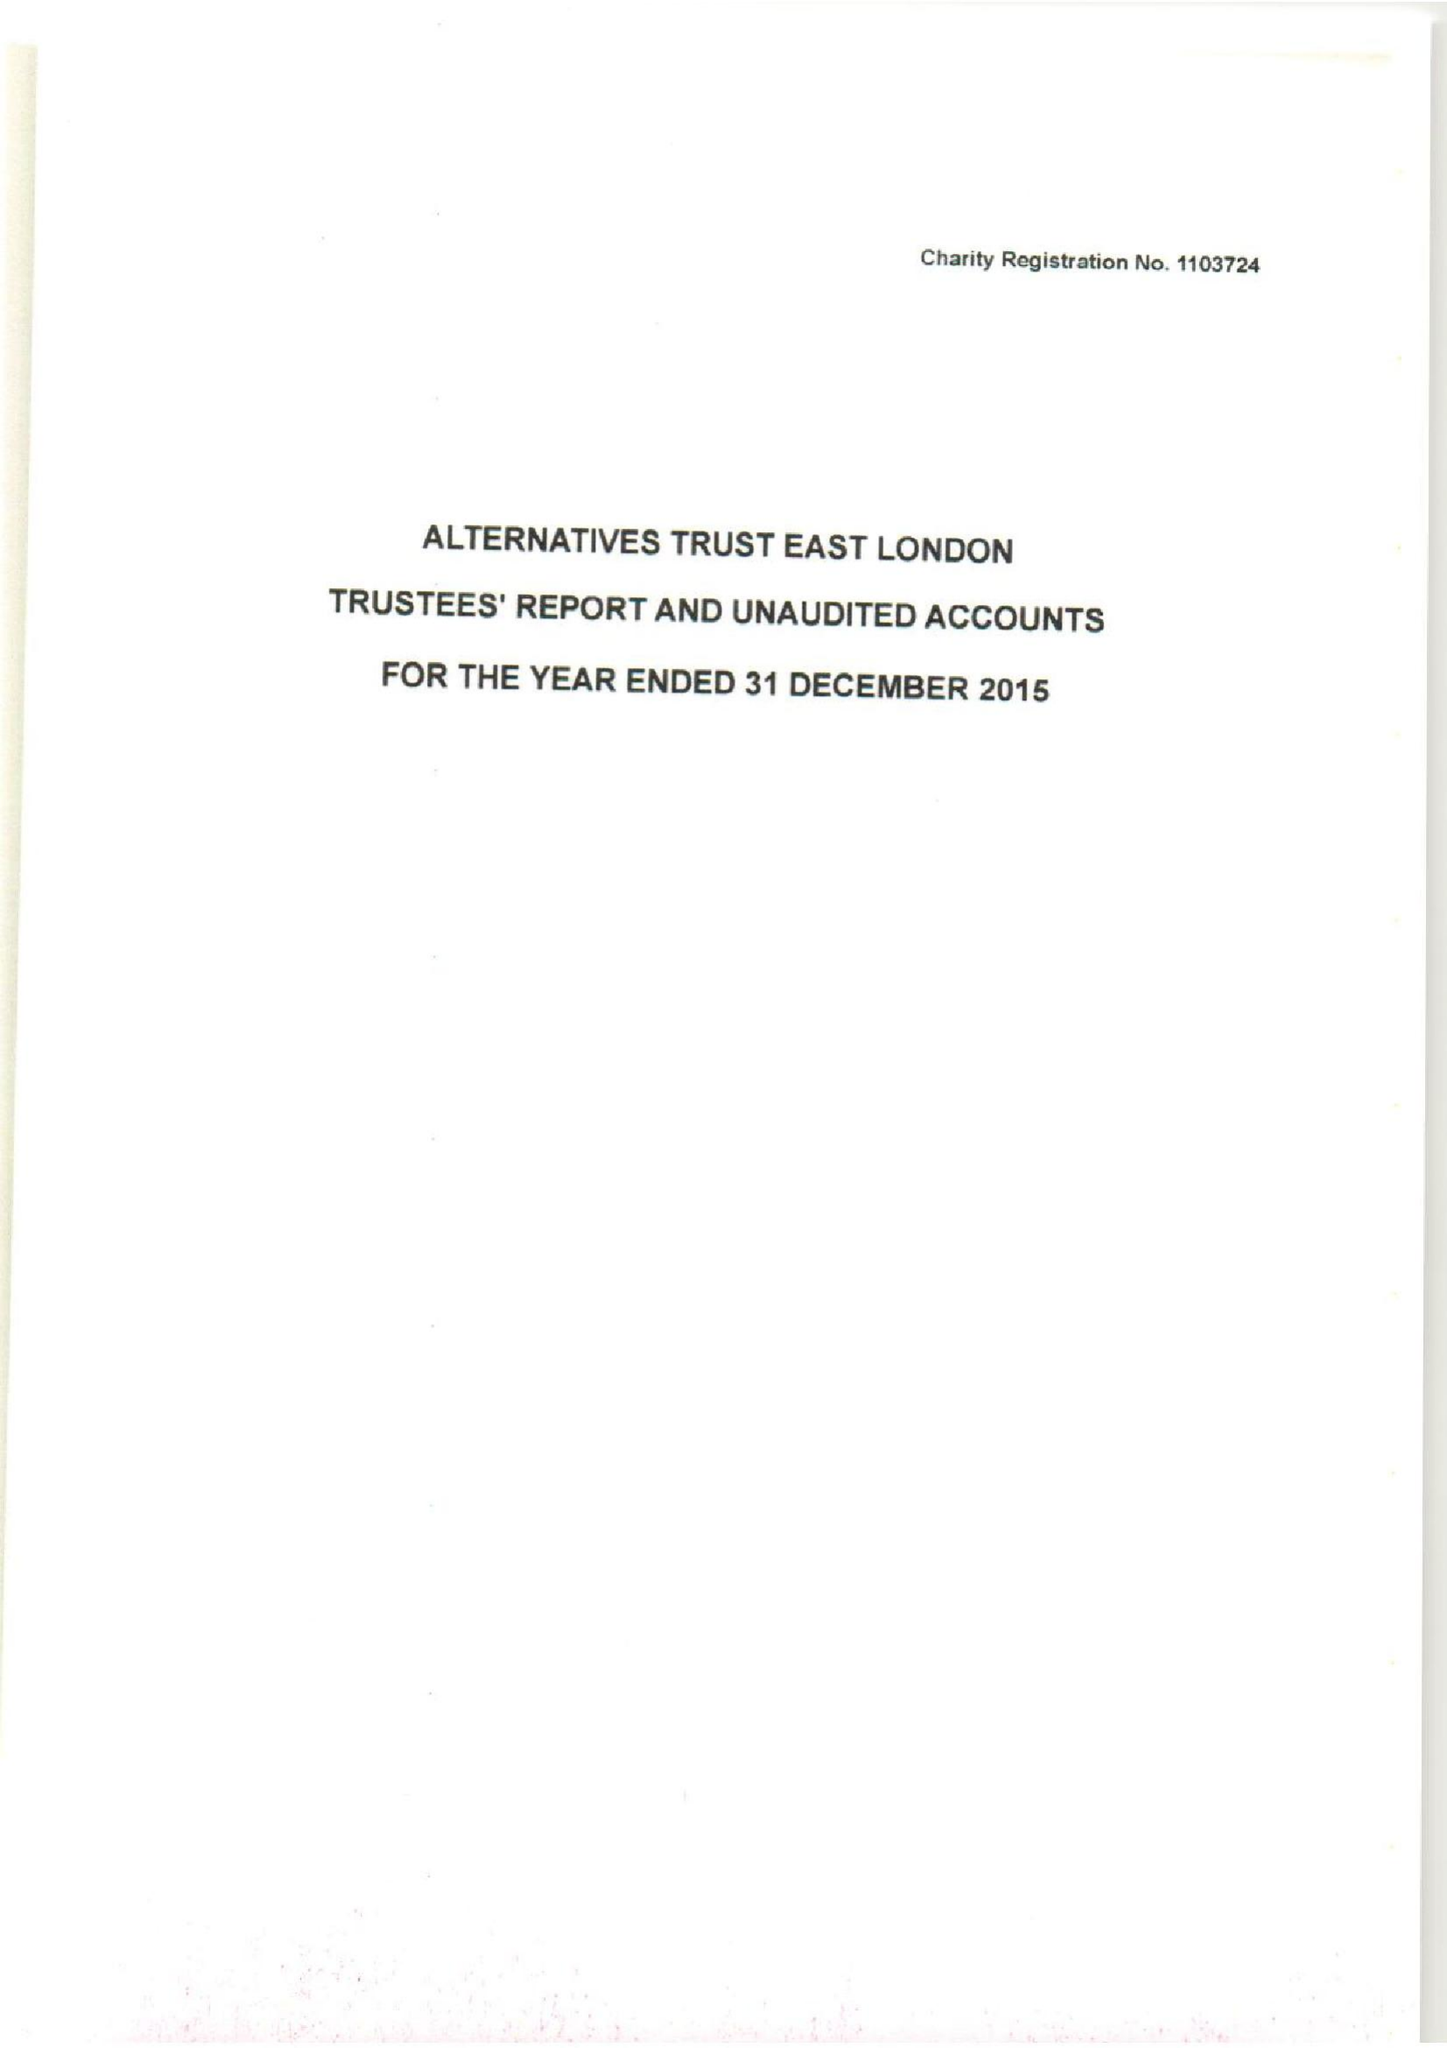What is the value for the spending_annually_in_british_pounds?
Answer the question using a single word or phrase. 118232.00 